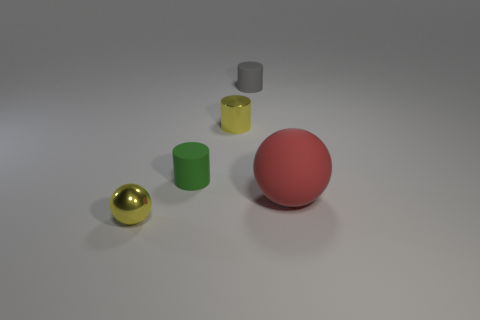Add 1 red things. How many objects exist? 6 Subtract all spheres. How many objects are left? 3 Add 2 green cubes. How many green cubes exist? 2 Subtract 1 green cylinders. How many objects are left? 4 Subtract all large purple metallic blocks. Subtract all tiny matte things. How many objects are left? 3 Add 5 rubber objects. How many rubber objects are left? 8 